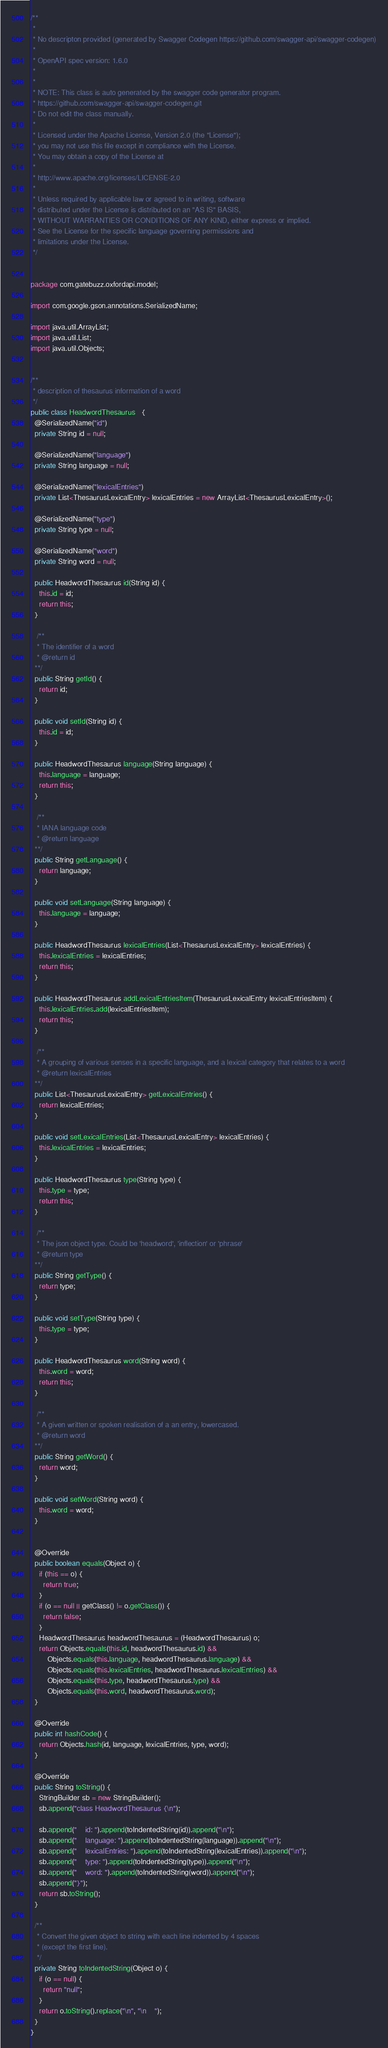Convert code to text. <code><loc_0><loc_0><loc_500><loc_500><_Java_>/**
 * 
 * No descripton provided (generated by Swagger Codegen https://github.com/swagger-api/swagger-codegen)
 *
 * OpenAPI spec version: 1.6.0
 * 
 *
 * NOTE: This class is auto generated by the swagger code generator program.
 * https://github.com/swagger-api/swagger-codegen.git
 * Do not edit the class manually.
 *
 * Licensed under the Apache License, Version 2.0 (the "License");
 * you may not use this file except in compliance with the License.
 * You may obtain a copy of the License at
 *
 * http://www.apache.org/licenses/LICENSE-2.0
 *
 * Unless required by applicable law or agreed to in writing, software
 * distributed under the License is distributed on an "AS IS" BASIS,
 * WITHOUT WARRANTIES OR CONDITIONS OF ANY KIND, either express or implied.
 * See the License for the specific language governing permissions and
 * limitations under the License.
 */


package com.gatebuzz.oxfordapi.model;

import com.google.gson.annotations.SerializedName;

import java.util.ArrayList;
import java.util.List;
import java.util.Objects;


/**
 * description of thesaurus information of a word
 */
public class HeadwordThesaurus   {
  @SerializedName("id")
  private String id = null;

  @SerializedName("language")
  private String language = null;

  @SerializedName("lexicalEntries")
  private List<ThesaurusLexicalEntry> lexicalEntries = new ArrayList<ThesaurusLexicalEntry>();

  @SerializedName("type")
  private String type = null;

  @SerializedName("word")
  private String word = null;

  public HeadwordThesaurus id(String id) {
    this.id = id;
    return this;
  }

   /**
   * The identifier of a word
   * @return id
  **/
  public String getId() {
    return id;
  }

  public void setId(String id) {
    this.id = id;
  }

  public HeadwordThesaurus language(String language) {
    this.language = language;
    return this;
  }

   /**
   * IANA language code
   * @return language
  **/
  public String getLanguage() {
    return language;
  }

  public void setLanguage(String language) {
    this.language = language;
  }

  public HeadwordThesaurus lexicalEntries(List<ThesaurusLexicalEntry> lexicalEntries) {
    this.lexicalEntries = lexicalEntries;
    return this;
  }

  public HeadwordThesaurus addLexicalEntriesItem(ThesaurusLexicalEntry lexicalEntriesItem) {
    this.lexicalEntries.add(lexicalEntriesItem);
    return this;
  }

   /**
   * A grouping of various senses in a specific language, and a lexical category that relates to a word
   * @return lexicalEntries
  **/
  public List<ThesaurusLexicalEntry> getLexicalEntries() {
    return lexicalEntries;
  }

  public void setLexicalEntries(List<ThesaurusLexicalEntry> lexicalEntries) {
    this.lexicalEntries = lexicalEntries;
  }

  public HeadwordThesaurus type(String type) {
    this.type = type;
    return this;
  }

   /**
   * The json object type. Could be 'headword', 'inflection' or 'phrase'
   * @return type
  **/
  public String getType() {
    return type;
  }

  public void setType(String type) {
    this.type = type;
  }

  public HeadwordThesaurus word(String word) {
    this.word = word;
    return this;
  }

   /**
   * A given written or spoken realisation of a an entry, lowercased.
   * @return word
  **/
  public String getWord() {
    return word;
  }

  public void setWord(String word) {
    this.word = word;
  }


  @Override
  public boolean equals(Object o) {
    if (this == o) {
      return true;
    }
    if (o == null || getClass() != o.getClass()) {
      return false;
    }
    HeadwordThesaurus headwordThesaurus = (HeadwordThesaurus) o;
    return Objects.equals(this.id, headwordThesaurus.id) &&
        Objects.equals(this.language, headwordThesaurus.language) &&
        Objects.equals(this.lexicalEntries, headwordThesaurus.lexicalEntries) &&
        Objects.equals(this.type, headwordThesaurus.type) &&
        Objects.equals(this.word, headwordThesaurus.word);
  }

  @Override
  public int hashCode() {
    return Objects.hash(id, language, lexicalEntries, type, word);
  }

  @Override
  public String toString() {
    StringBuilder sb = new StringBuilder();
    sb.append("class HeadwordThesaurus {\n");
    
    sb.append("    id: ").append(toIndentedString(id)).append("\n");
    sb.append("    language: ").append(toIndentedString(language)).append("\n");
    sb.append("    lexicalEntries: ").append(toIndentedString(lexicalEntries)).append("\n");
    sb.append("    type: ").append(toIndentedString(type)).append("\n");
    sb.append("    word: ").append(toIndentedString(word)).append("\n");
    sb.append("}");
    return sb.toString();
  }

  /**
   * Convert the given object to string with each line indented by 4 spaces
   * (except the first line).
   */
  private String toIndentedString(Object o) {
    if (o == null) {
      return "null";
    }
    return o.toString().replace("\n", "\n    ");
  }
}

</code> 